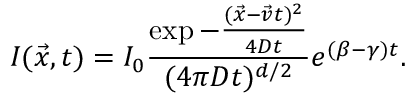<formula> <loc_0><loc_0><loc_500><loc_500>I ( \vec { x } , t ) = I _ { 0 } \frac { \exp { - \frac { ( \vec { x } - \vec { v } t ) ^ { 2 } } { 4 D t } } } { ( 4 \pi D t ) ^ { d / 2 } } e ^ { ( \beta - \gamma ) t } .</formula> 